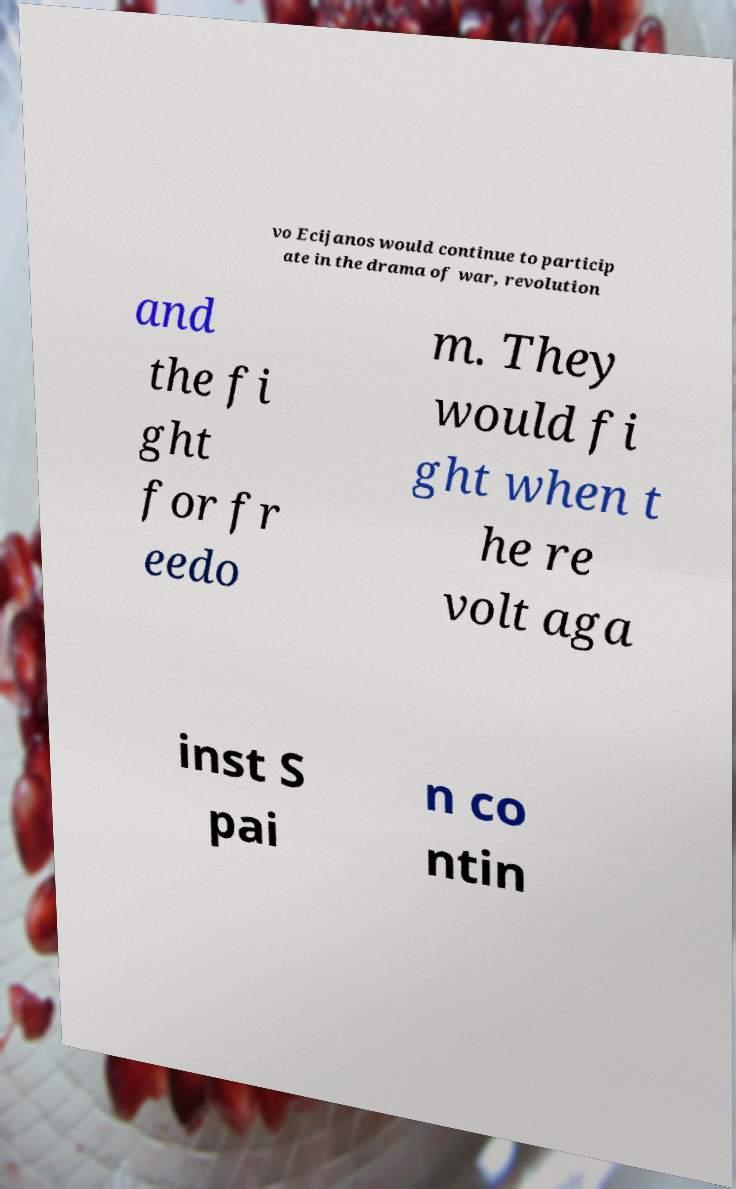Can you accurately transcribe the text from the provided image for me? vo Ecijanos would continue to particip ate in the drama of war, revolution and the fi ght for fr eedo m. They would fi ght when t he re volt aga inst S pai n co ntin 